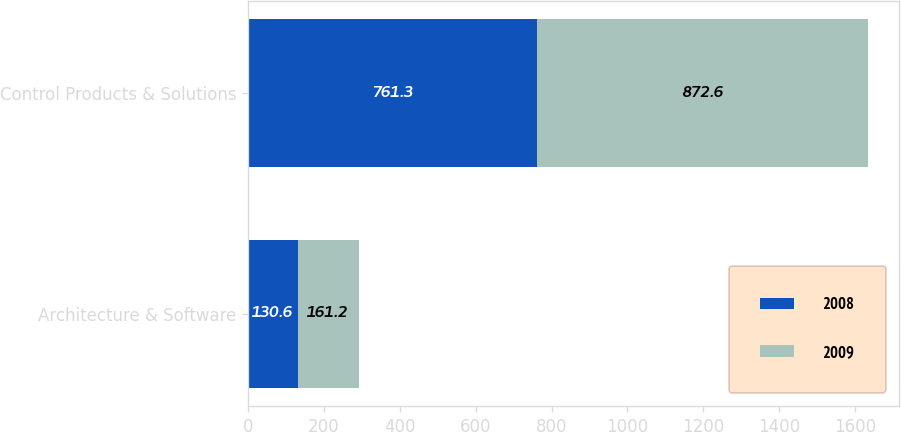Convert chart to OTSL. <chart><loc_0><loc_0><loc_500><loc_500><stacked_bar_chart><ecel><fcel>Architecture & Software<fcel>Control Products & Solutions<nl><fcel>2008<fcel>130.6<fcel>761.3<nl><fcel>2009<fcel>161.2<fcel>872.6<nl></chart> 